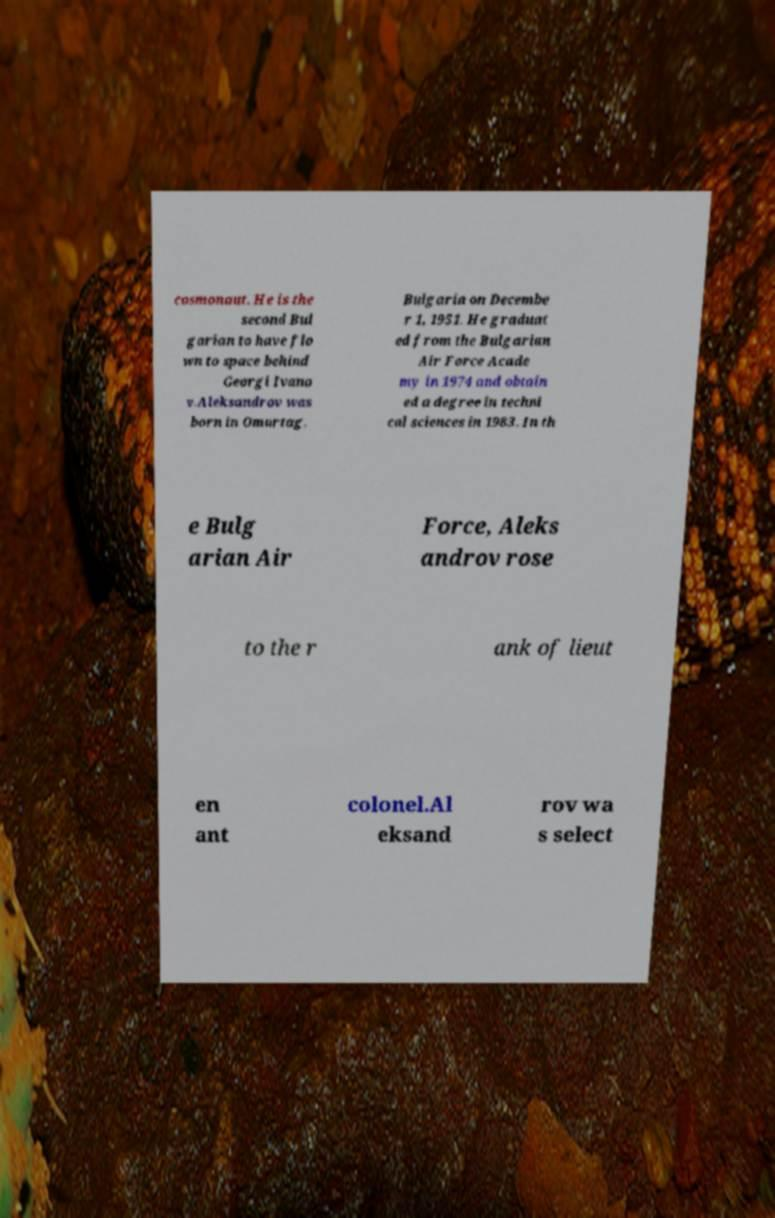Please read and relay the text visible in this image. What does it say? cosmonaut. He is the second Bul garian to have flo wn to space behind Georgi Ivano v.Aleksandrov was born in Omurtag, Bulgaria on Decembe r 1, 1951. He graduat ed from the Bulgarian Air Force Acade my in 1974 and obtain ed a degree in techni cal sciences in 1983. In th e Bulg arian Air Force, Aleks androv rose to the r ank of lieut en ant colonel.Al eksand rov wa s select 